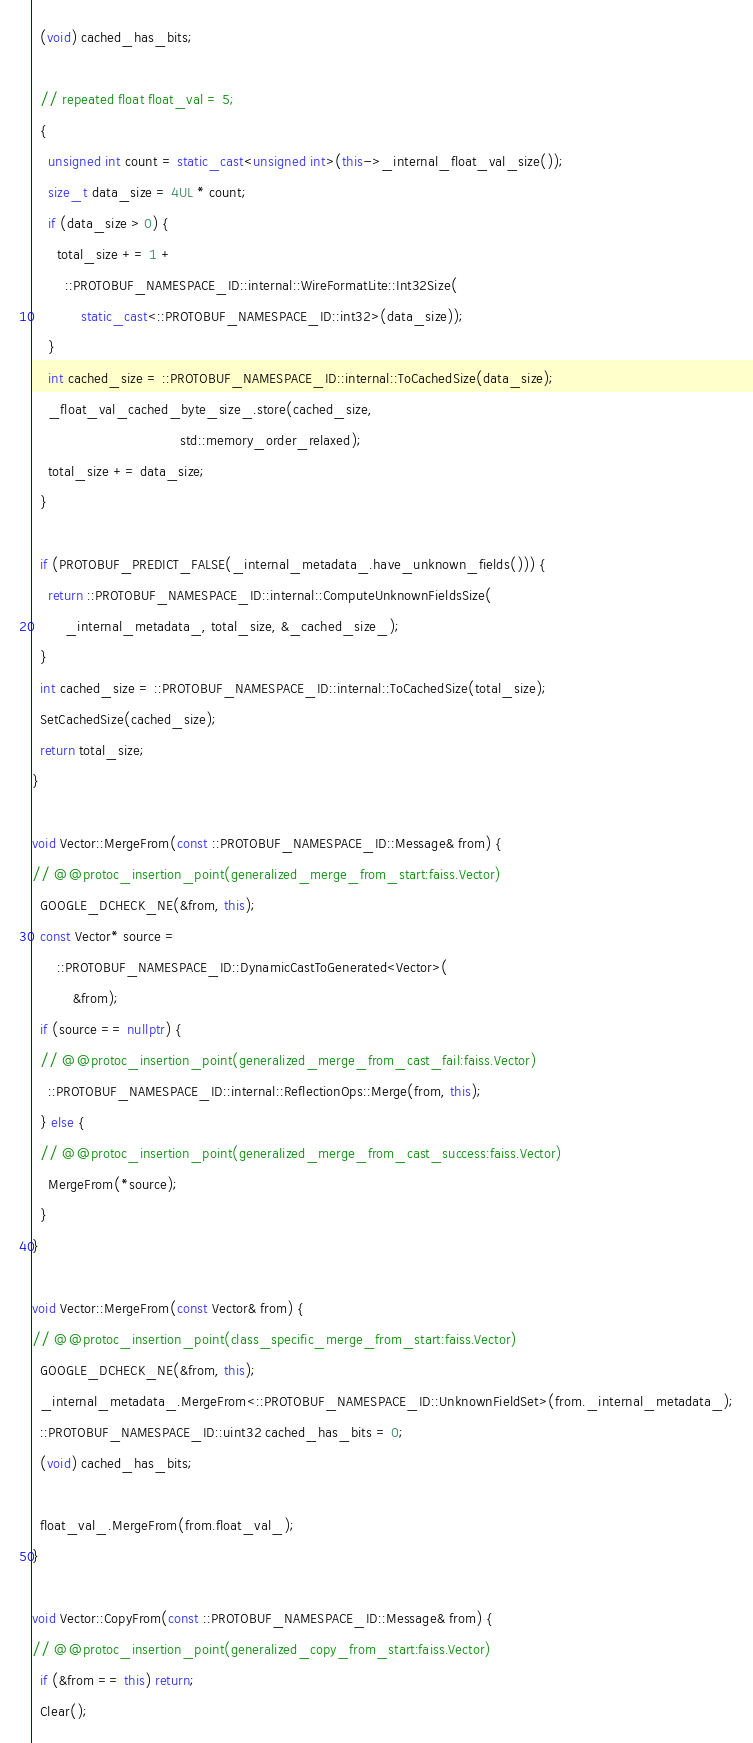Convert code to text. <code><loc_0><loc_0><loc_500><loc_500><_C++_>  (void) cached_has_bits;

  // repeated float float_val = 5;
  {
    unsigned int count = static_cast<unsigned int>(this->_internal_float_val_size());
    size_t data_size = 4UL * count;
    if (data_size > 0) {
      total_size += 1 +
        ::PROTOBUF_NAMESPACE_ID::internal::WireFormatLite::Int32Size(
            static_cast<::PROTOBUF_NAMESPACE_ID::int32>(data_size));
    }
    int cached_size = ::PROTOBUF_NAMESPACE_ID::internal::ToCachedSize(data_size);
    _float_val_cached_byte_size_.store(cached_size,
                                    std::memory_order_relaxed);
    total_size += data_size;
  }

  if (PROTOBUF_PREDICT_FALSE(_internal_metadata_.have_unknown_fields())) {
    return ::PROTOBUF_NAMESPACE_ID::internal::ComputeUnknownFieldsSize(
        _internal_metadata_, total_size, &_cached_size_);
  }
  int cached_size = ::PROTOBUF_NAMESPACE_ID::internal::ToCachedSize(total_size);
  SetCachedSize(cached_size);
  return total_size;
}

void Vector::MergeFrom(const ::PROTOBUF_NAMESPACE_ID::Message& from) {
// @@protoc_insertion_point(generalized_merge_from_start:faiss.Vector)
  GOOGLE_DCHECK_NE(&from, this);
  const Vector* source =
      ::PROTOBUF_NAMESPACE_ID::DynamicCastToGenerated<Vector>(
          &from);
  if (source == nullptr) {
  // @@protoc_insertion_point(generalized_merge_from_cast_fail:faiss.Vector)
    ::PROTOBUF_NAMESPACE_ID::internal::ReflectionOps::Merge(from, this);
  } else {
  // @@protoc_insertion_point(generalized_merge_from_cast_success:faiss.Vector)
    MergeFrom(*source);
  }
}

void Vector::MergeFrom(const Vector& from) {
// @@protoc_insertion_point(class_specific_merge_from_start:faiss.Vector)
  GOOGLE_DCHECK_NE(&from, this);
  _internal_metadata_.MergeFrom<::PROTOBUF_NAMESPACE_ID::UnknownFieldSet>(from._internal_metadata_);
  ::PROTOBUF_NAMESPACE_ID::uint32 cached_has_bits = 0;
  (void) cached_has_bits;

  float_val_.MergeFrom(from.float_val_);
}

void Vector::CopyFrom(const ::PROTOBUF_NAMESPACE_ID::Message& from) {
// @@protoc_insertion_point(generalized_copy_from_start:faiss.Vector)
  if (&from == this) return;
  Clear();</code> 